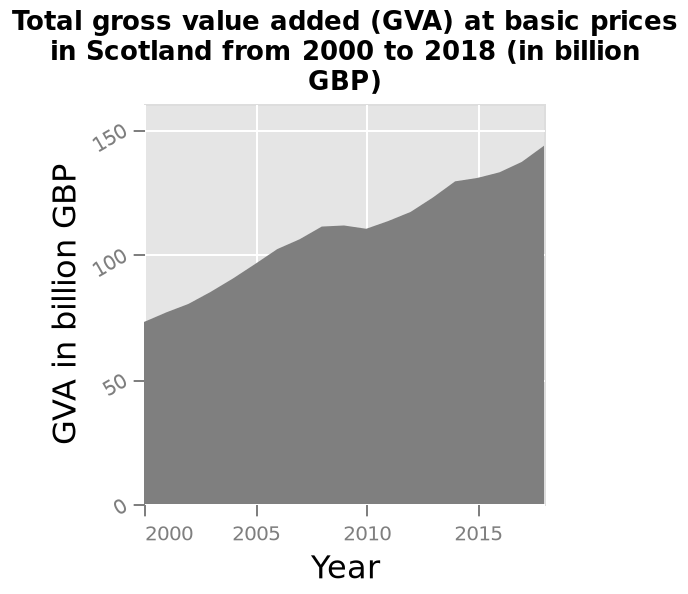<image>
What is the variable being plotted on the x-axis?  The variable being plotted on the x-axis is Year. What is the unit of measurement for the data plotted on the y-axis?  The unit of measurement for the data plotted on the y-axis is billion GBP. What is the range of years for which the data is plotted?  The range of years for which the data is plotted is from 2000 to 2018. 